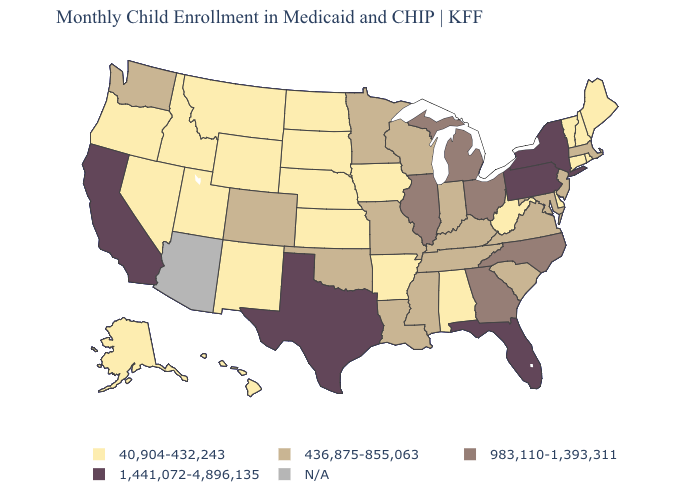Does Pennsylvania have the highest value in the Northeast?
Write a very short answer. Yes. What is the value of Nevada?
Give a very brief answer. 40,904-432,243. What is the value of Michigan?
Answer briefly. 983,110-1,393,311. What is the value of Maine?
Concise answer only. 40,904-432,243. What is the value of Ohio?
Answer briefly. 983,110-1,393,311. Does Florida have the highest value in the South?
Keep it brief. Yes. Does the map have missing data?
Give a very brief answer. Yes. How many symbols are there in the legend?
Write a very short answer. 5. Does Alabama have the highest value in the South?
Keep it brief. No. Among the states that border Arizona , which have the lowest value?
Keep it brief. Nevada, New Mexico, Utah. What is the value of Maryland?
Concise answer only. 436,875-855,063. Name the states that have a value in the range N/A?
Be succinct. Arizona. Name the states that have a value in the range 436,875-855,063?
Give a very brief answer. Colorado, Indiana, Kentucky, Louisiana, Maryland, Massachusetts, Minnesota, Mississippi, Missouri, New Jersey, Oklahoma, South Carolina, Tennessee, Virginia, Washington, Wisconsin. What is the lowest value in the USA?
Be succinct. 40,904-432,243. 